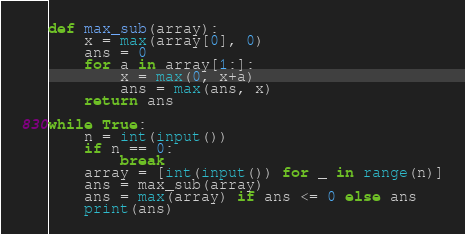<code> <loc_0><loc_0><loc_500><loc_500><_Python_>def max_sub(array):
    x = max(array[0], 0)
    ans = 0
    for a in array[1:]:
        x = max(0, x+a)
        ans = max(ans, x)
    return ans

while True:
    n = int(input())
    if n == 0:
        break
    array = [int(input()) for _ in range(n)]
    ans = max_sub(array)
    ans = max(array) if ans <= 0 else ans
    print(ans)

</code> 